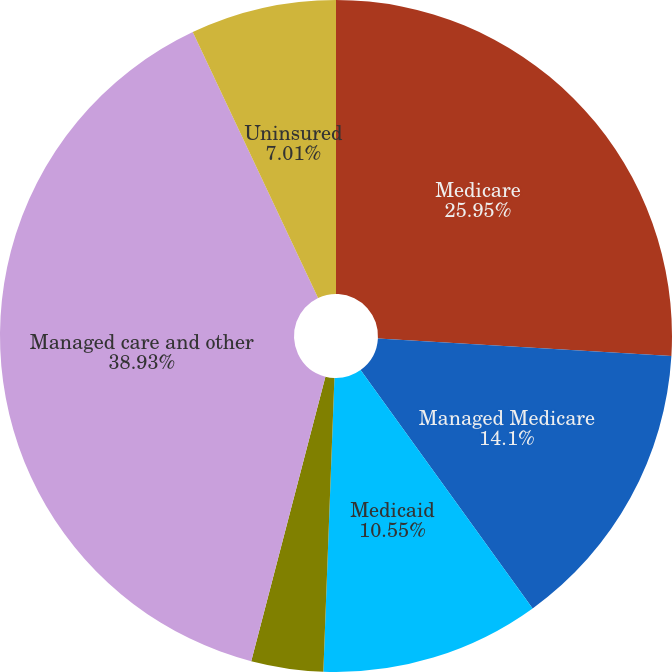Convert chart to OTSL. <chart><loc_0><loc_0><loc_500><loc_500><pie_chart><fcel>Medicare<fcel>Managed Medicare<fcel>Medicaid<fcel>Managed Medicaid<fcel>Managed care and other<fcel>Uninsured<nl><fcel>25.95%<fcel>14.1%<fcel>10.55%<fcel>3.46%<fcel>38.93%<fcel>7.01%<nl></chart> 